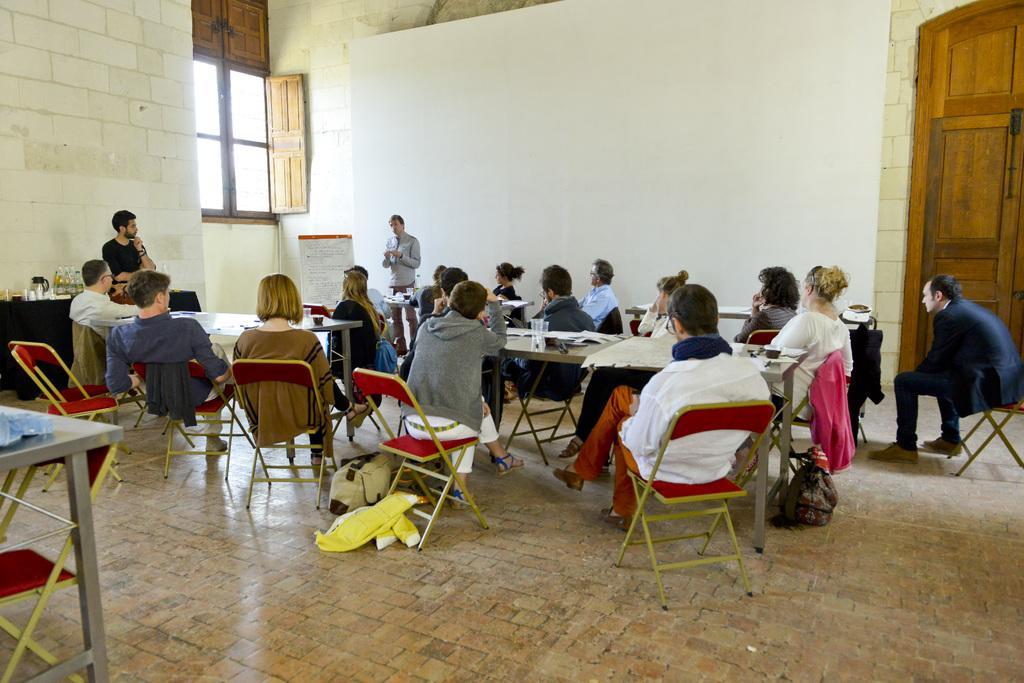Describe this image in one or two sentences. There are group of people sitting in red chairs and there is a table in front of them which has some papers on it and there are two persons standing in front of them. 